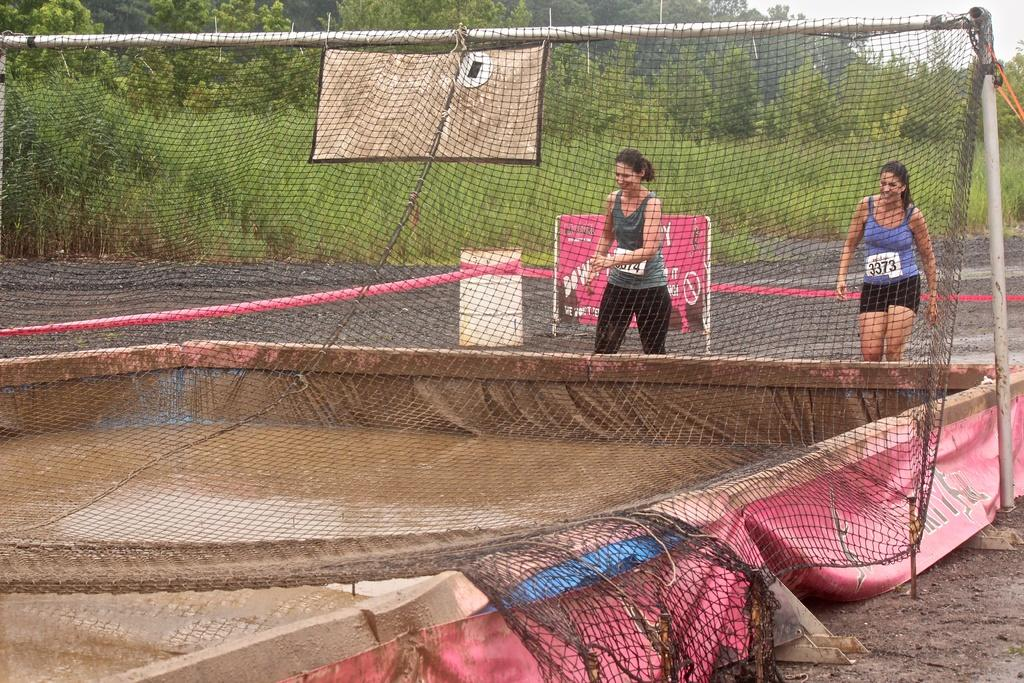Who is present in the image? There are ladies in the image. What object can be seen in the image? There is a net in the image. What natural element is visible in the image? There is water visible in the image. What can be seen in the background of the image? There are trees and the sky visible in the background of the image. What type of jam is being distributed by the ladies in the image? There is no jam present in the image, nor are the ladies distributing anything. 